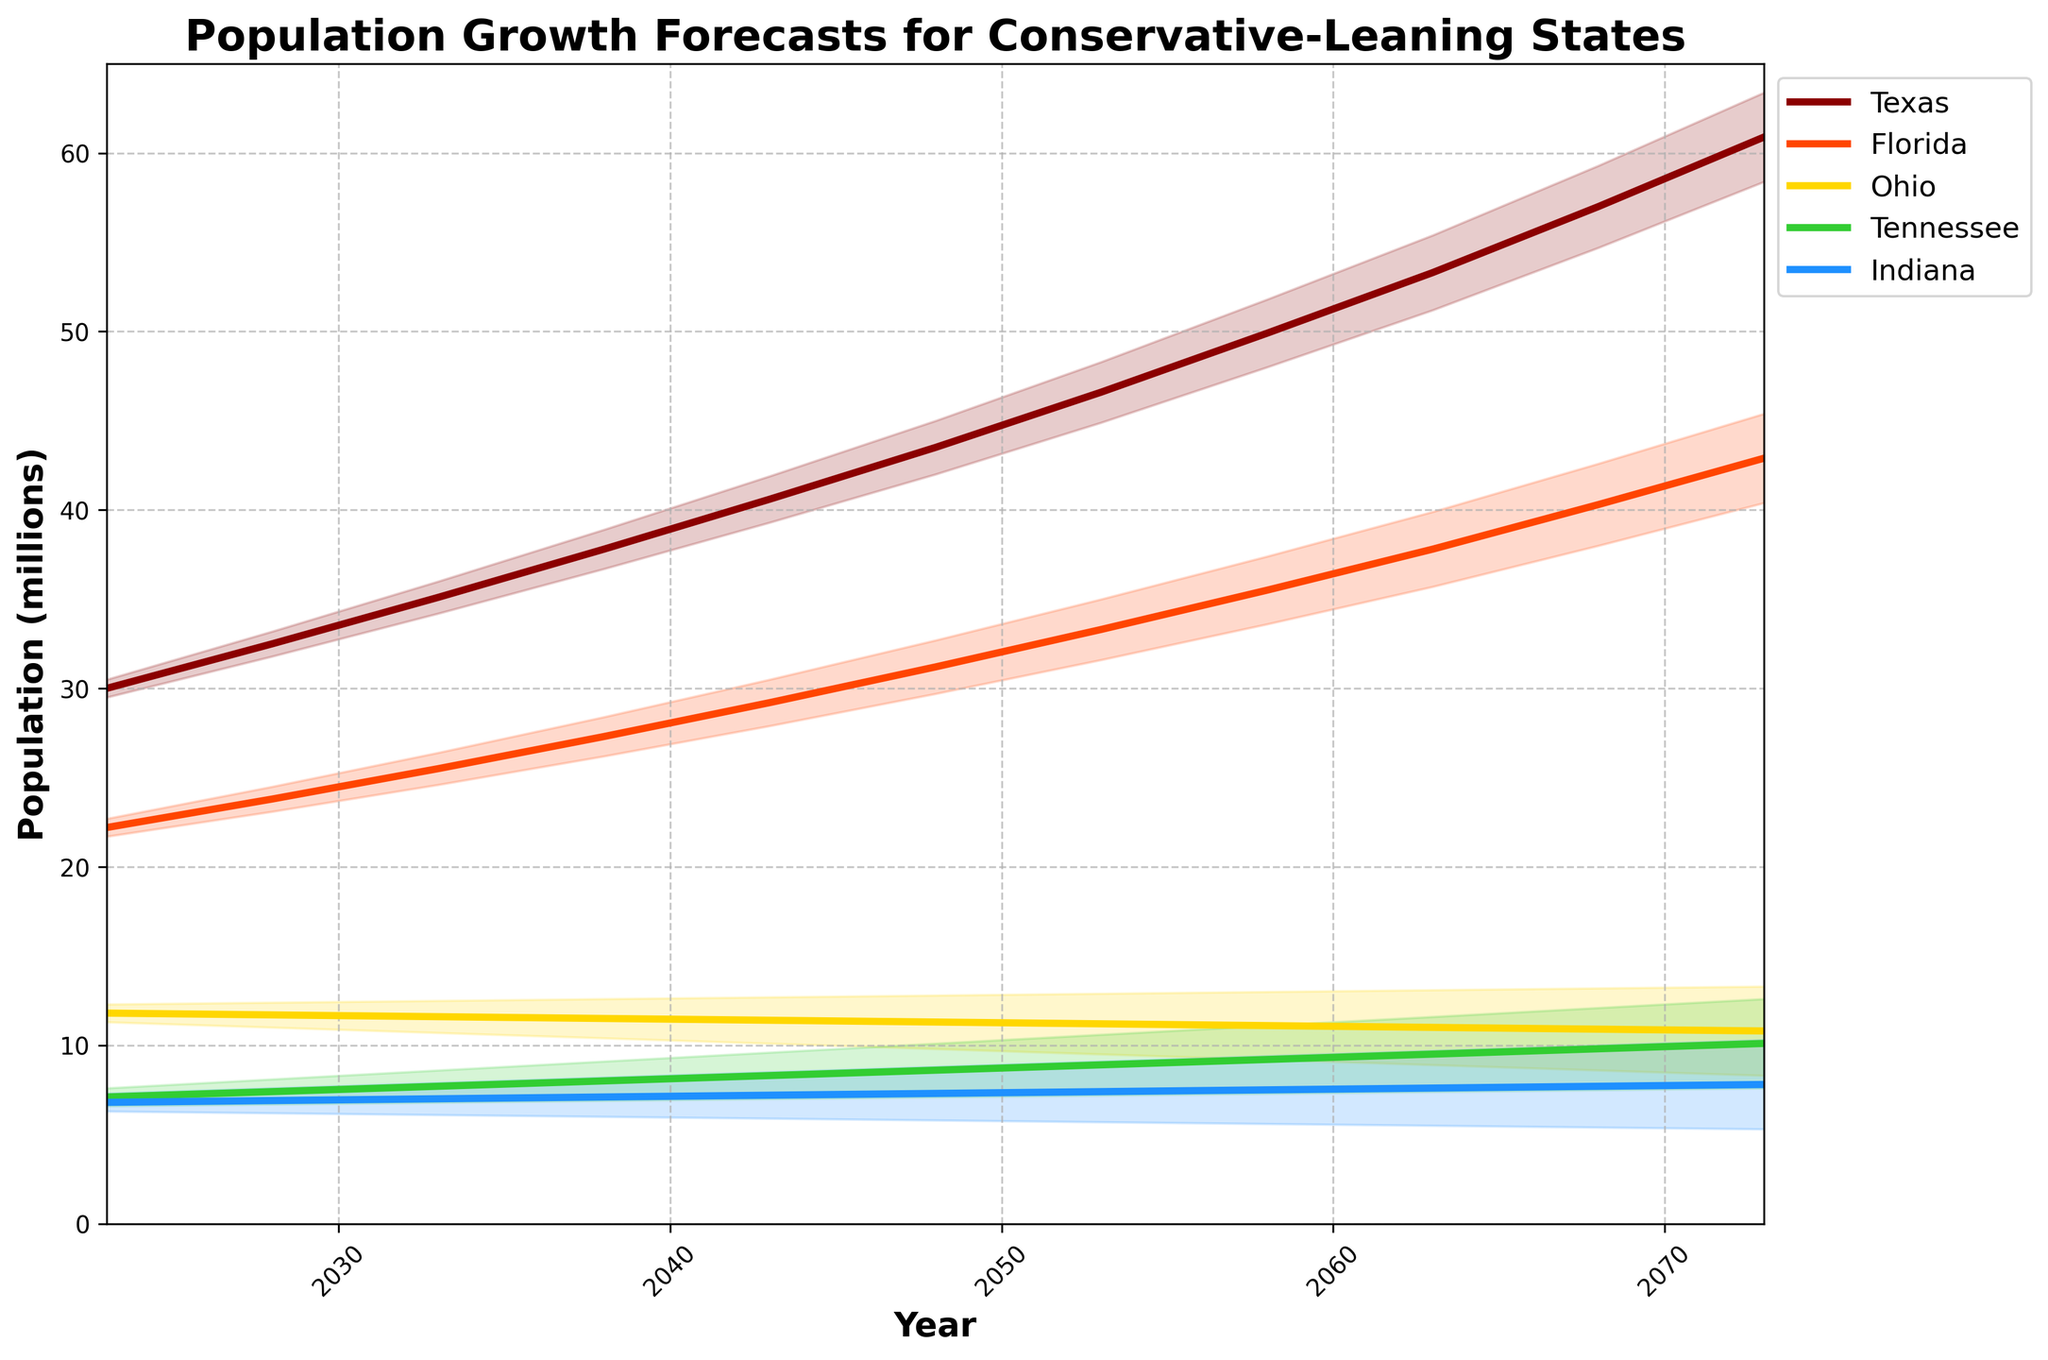What is the title of the figure? The title is typically located at the top of the figure and summarizes what the chart represents.
Answer: Population Growth Forecasts for Conservative-Leaning States What are the states shown in the figure? The states can be identified from the legend on the figure.
Answer: Texas, Florida, Ohio, Tennessee, Indiana Which state has the highest population forecast in 2073? By observing the last data point for each state on the chart, we can determine which line is at the highest value.
Answer: Texas In which year does Florida’s population forecast first exceed 30 million? Locate the data points for Florida along the x-axis and identify when the population first crosses 30 million.
Answer: 2048 What is the range of Texas's population forecast in 2068 including the uncertainty? The range is determined by the upper and lower boundaries of the fan chart around the Texas line for 2068.
Answer: Approximately 55.5 to 58.5 million Which state shows a population decrease over the forecast period? Look for any lines that trend downwards over the entire period.
Answer: Ohio How does the uncertainty of Tennessee's forecast compare from 2023 to 2073? Examine the width of the fan chart (between upper and lower bounds) for Tennessee at both the start and end of the period.
Answer: The uncertainty increases Which state has the smallest population forecast in 2023? Identify the lowest data point on the y-axis for the year 2023.
Answer: Indiana What is the total predicted population of the five states in 2043? Sum the population forecasts for all five states in the year 2043.
Answer: 96.7 million Between which years does Texas experience the highest population growth rate? By comparing the slope of the Texas line, identify the period with the steepest incline.
Answer: 2023 to 2028 